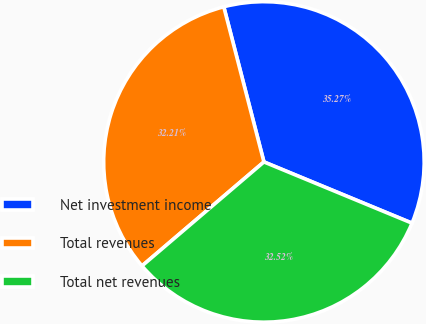Convert chart. <chart><loc_0><loc_0><loc_500><loc_500><pie_chart><fcel>Net investment income<fcel>Total revenues<fcel>Total net revenues<nl><fcel>35.27%<fcel>32.21%<fcel>32.52%<nl></chart> 